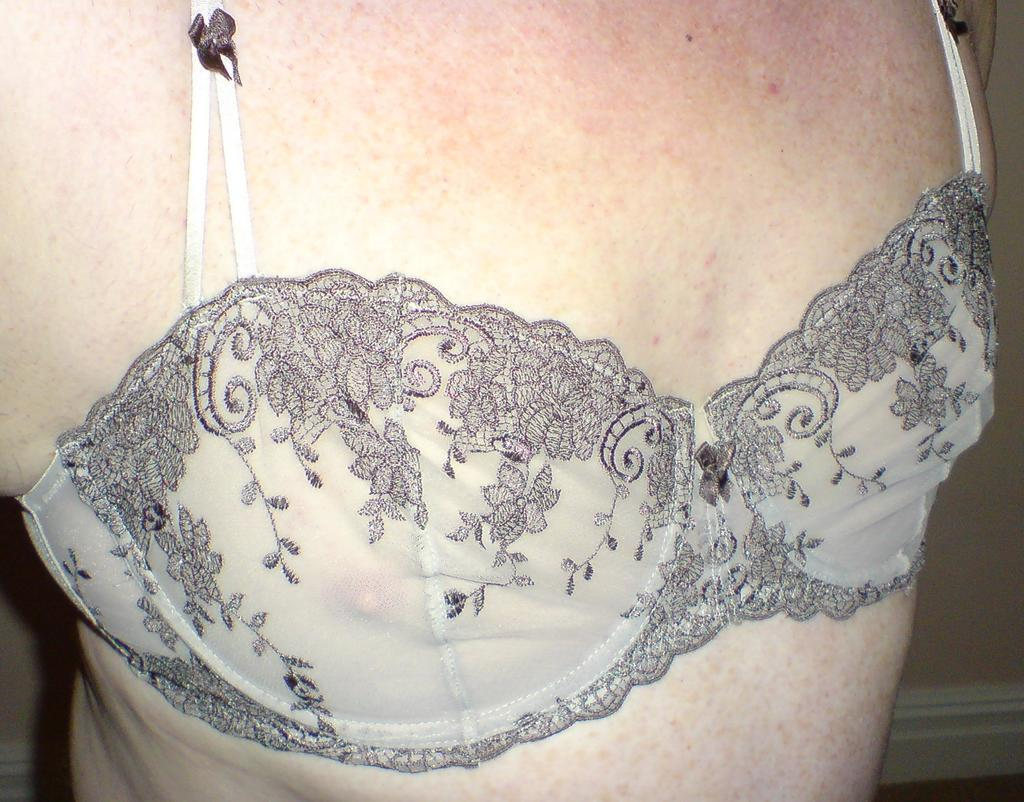What is the main subject of the image? There is a person's body in the image. What type of laborer is working in the background of the image? There is no laborer or background present in the image; it only features a person's body. 